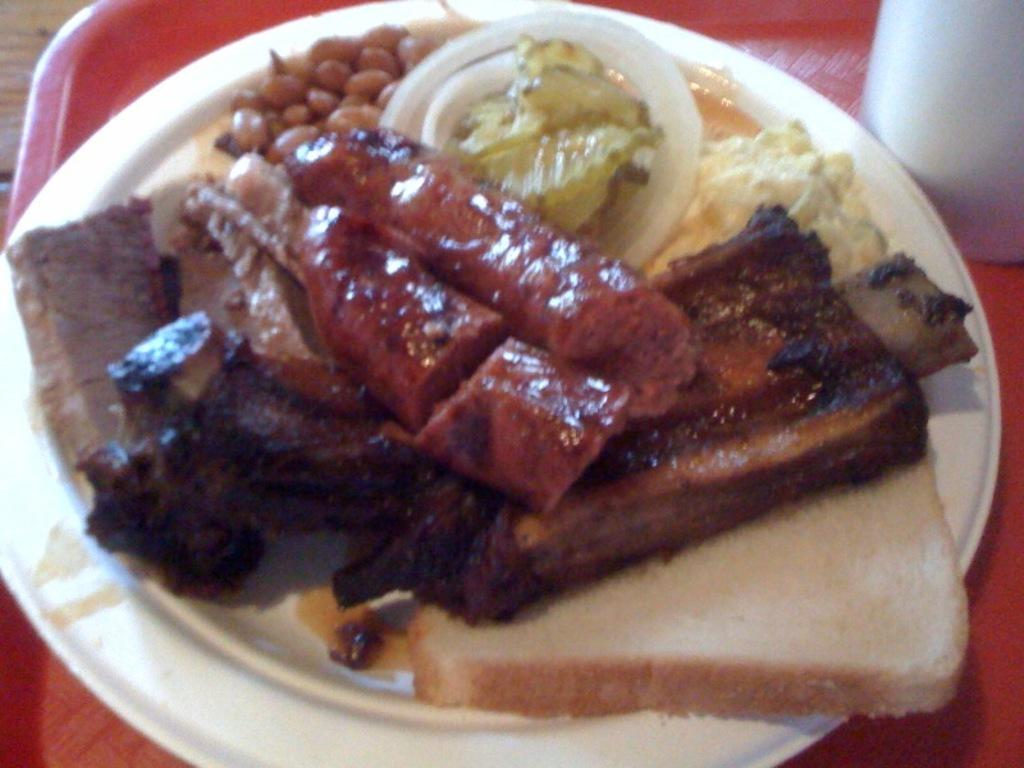What is on the tray that is visible in the image? There is food on a tray in the image. What else can be seen on the tray besides the food? There is a glass on the tray in the image. Where is the tray located in the image? The tray is on a table in the image. What color is the eye of the person in the image? There is no person or eye present in the image; it only features a tray with food and a glass on a table. 